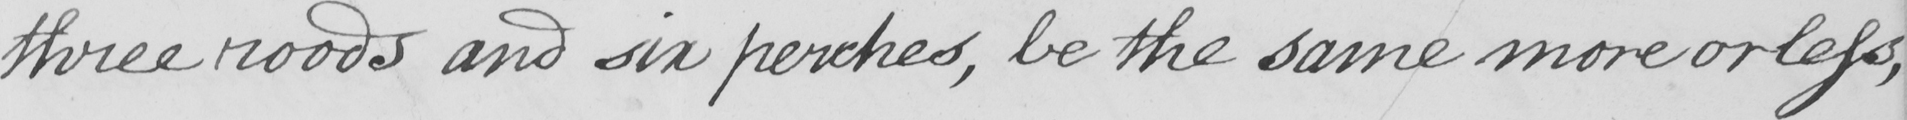What does this handwritten line say? three roads and six perches , be the same more or less , 